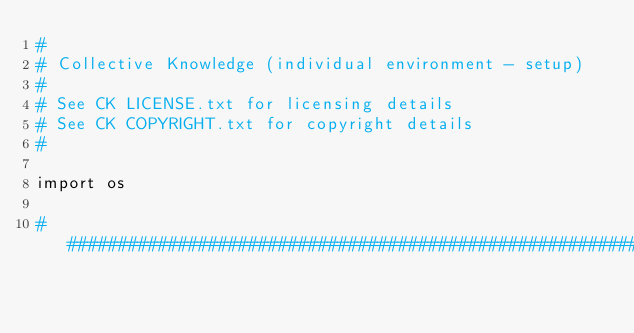<code> <loc_0><loc_0><loc_500><loc_500><_Python_>#
# Collective Knowledge (individual environment - setup)
#
# See CK LICENSE.txt for licensing details
# See CK COPYRIGHT.txt for copyright details
#

import os

##############################################################################</code> 